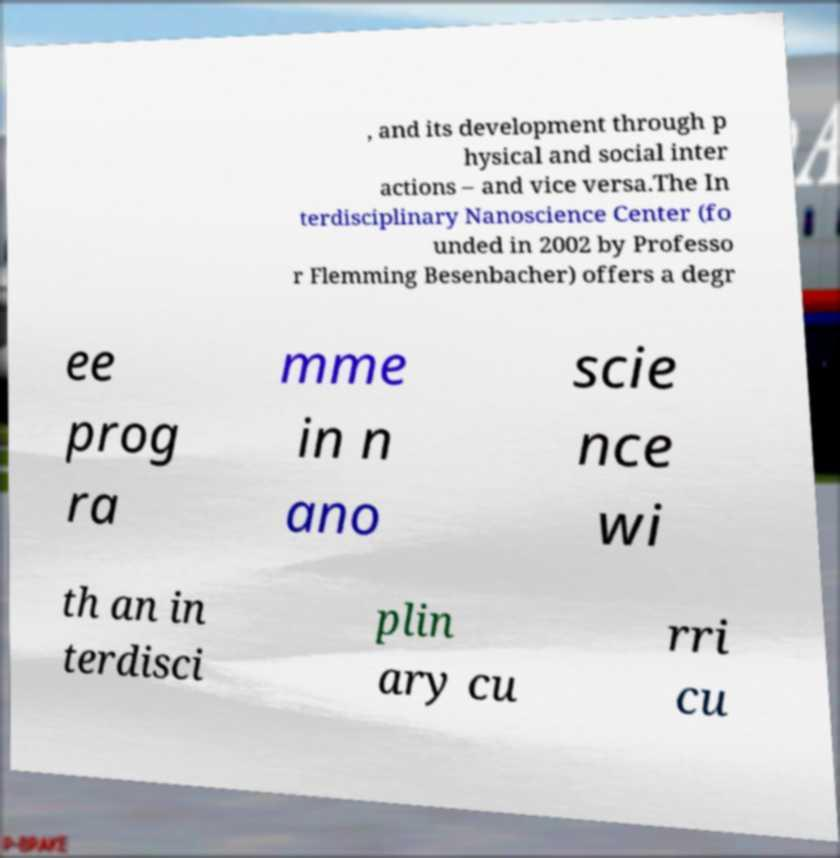What messages or text are displayed in this image? I need them in a readable, typed format. , and its development through p hysical and social inter actions – and vice versa.The In terdisciplinary Nanoscience Center (fo unded in 2002 by Professo r Flemming Besenbacher) offers a degr ee prog ra mme in n ano scie nce wi th an in terdisci plin ary cu rri cu 